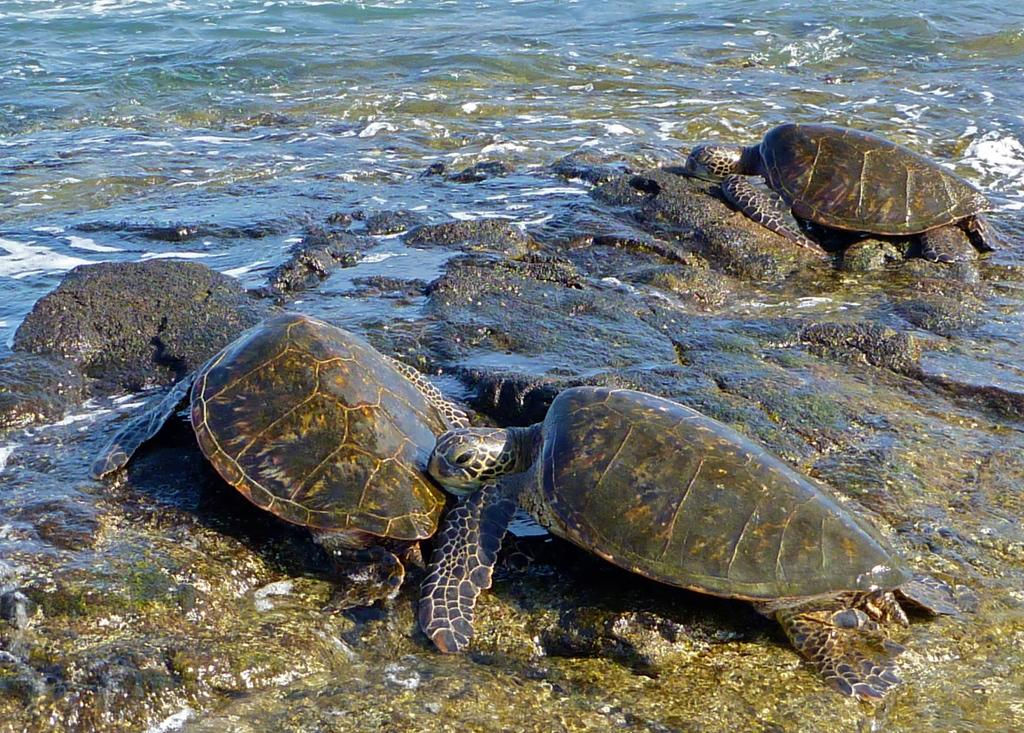What type of animals are in the image? There are tortoises in the image. What colors can be seen on the tortoises? The tortoises are in black, brown, and cream colors. What is visible in the background of the image? There is water visible in the image. What type of terrain is present in the image? There are stones in the image. What type of instrument is being played by the tortoises in the image? There is no instrument being played by the tortoises in the image; they are simply present in the scene. 